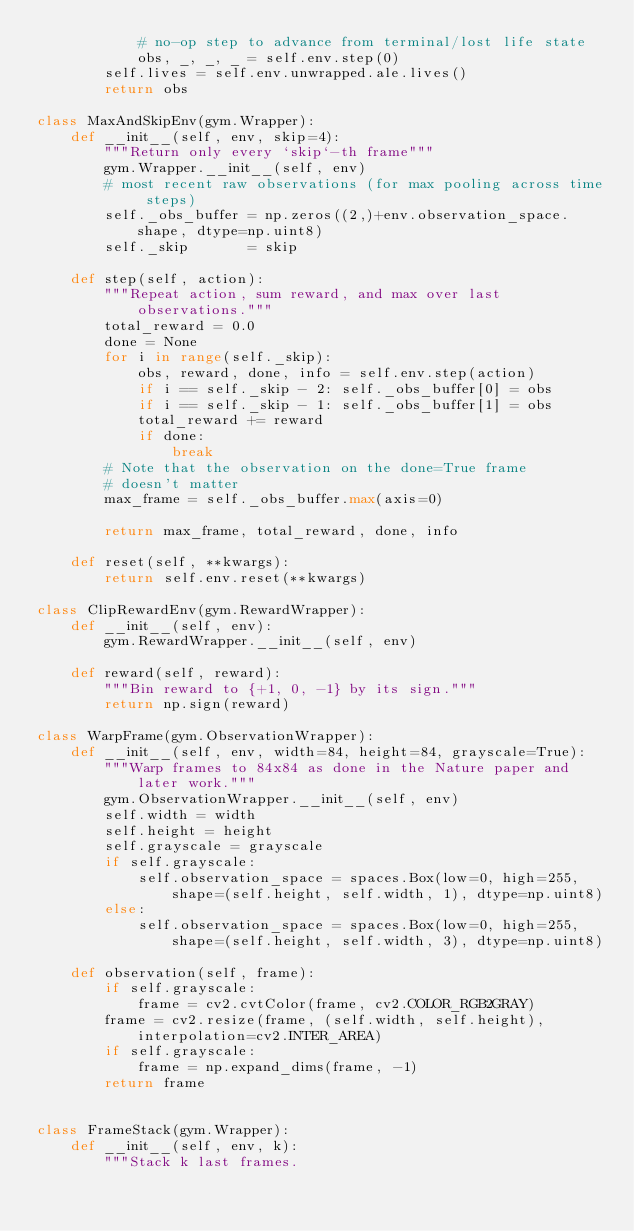Convert code to text. <code><loc_0><loc_0><loc_500><loc_500><_Python_>            # no-op step to advance from terminal/lost life state
            obs, _, _, _ = self.env.step(0)
        self.lives = self.env.unwrapped.ale.lives()
        return obs

class MaxAndSkipEnv(gym.Wrapper):
    def __init__(self, env, skip=4):
        """Return only every `skip`-th frame"""
        gym.Wrapper.__init__(self, env)
        # most recent raw observations (for max pooling across time steps)
        self._obs_buffer = np.zeros((2,)+env.observation_space.shape, dtype=np.uint8)
        self._skip       = skip

    def step(self, action):
        """Repeat action, sum reward, and max over last observations."""
        total_reward = 0.0
        done = None
        for i in range(self._skip):
            obs, reward, done, info = self.env.step(action)
            if i == self._skip - 2: self._obs_buffer[0] = obs
            if i == self._skip - 1: self._obs_buffer[1] = obs
            total_reward += reward
            if done:
                break
        # Note that the observation on the done=True frame
        # doesn't matter
        max_frame = self._obs_buffer.max(axis=0)

        return max_frame, total_reward, done, info

    def reset(self, **kwargs):
        return self.env.reset(**kwargs)

class ClipRewardEnv(gym.RewardWrapper):
    def __init__(self, env):
        gym.RewardWrapper.__init__(self, env)

    def reward(self, reward):
        """Bin reward to {+1, 0, -1} by its sign."""
        return np.sign(reward)

class WarpFrame(gym.ObservationWrapper):
    def __init__(self, env, width=84, height=84, grayscale=True):
        """Warp frames to 84x84 as done in the Nature paper and later work."""
        gym.ObservationWrapper.__init__(self, env)
        self.width = width
        self.height = height
        self.grayscale = grayscale
        if self.grayscale:
            self.observation_space = spaces.Box(low=0, high=255,
                shape=(self.height, self.width, 1), dtype=np.uint8)
        else:
            self.observation_space = spaces.Box(low=0, high=255,
                shape=(self.height, self.width, 3), dtype=np.uint8)

    def observation(self, frame):
        if self.grayscale:
            frame = cv2.cvtColor(frame, cv2.COLOR_RGB2GRAY)
        frame = cv2.resize(frame, (self.width, self.height), interpolation=cv2.INTER_AREA)
        if self.grayscale:
            frame = np.expand_dims(frame, -1)
        return frame


class FrameStack(gym.Wrapper):
    def __init__(self, env, k):
        """Stack k last frames.</code> 